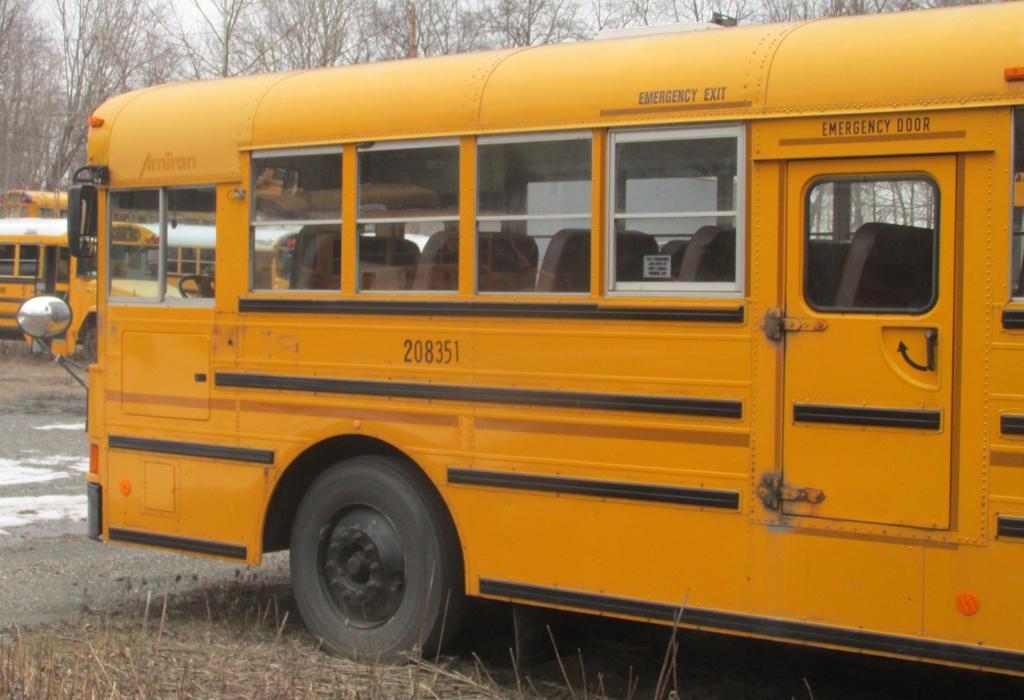In one or two sentences, can you explain what this image depicts? In this image we can see buses. On the ground there is grass. In the background there are trees. 